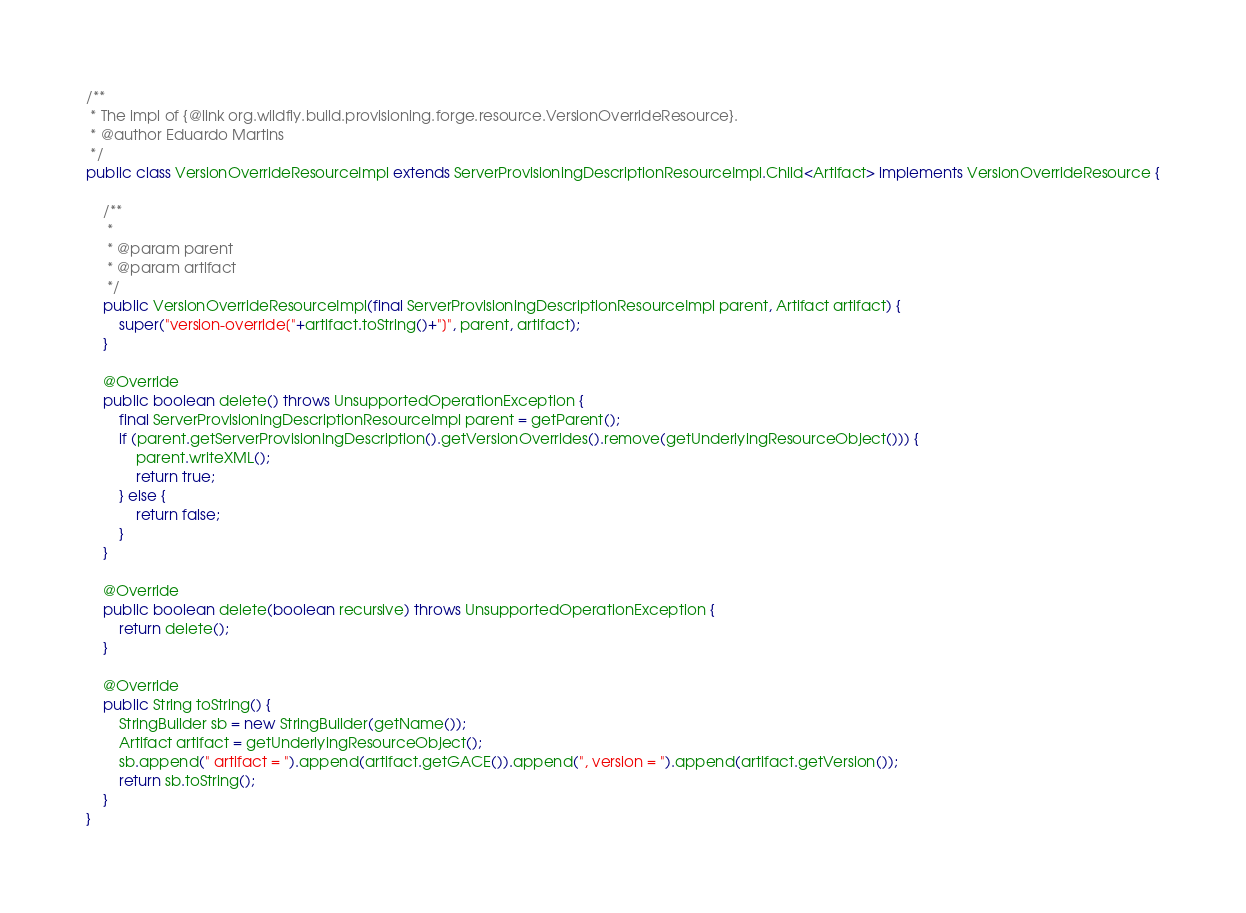<code> <loc_0><loc_0><loc_500><loc_500><_Java_>
/**
 * The impl of {@link org.wildfly.build.provisioning.forge.resource.VersionOverrideResource}.
 * @author Eduardo Martins
 */
public class VersionOverrideResourceImpl extends ServerProvisioningDescriptionResourceImpl.Child<Artifact> implements VersionOverrideResource {

    /**
     *
     * @param parent
     * @param artifact
     */
    public VersionOverrideResourceImpl(final ServerProvisioningDescriptionResourceImpl parent, Artifact artifact) {
        super("version-override["+artifact.toString()+"]", parent, artifact);
    }

    @Override
    public boolean delete() throws UnsupportedOperationException {
        final ServerProvisioningDescriptionResourceImpl parent = getParent();
        if (parent.getServerProvisioningDescription().getVersionOverrides().remove(getUnderlyingResourceObject())) {
            parent.writeXML();
            return true;
        } else {
            return false;
        }
    }

    @Override
    public boolean delete(boolean recursive) throws UnsupportedOperationException {
        return delete();
    }

    @Override
    public String toString() {
        StringBuilder sb = new StringBuilder(getName());
        Artifact artifact = getUnderlyingResourceObject();
        sb.append(" artifact = ").append(artifact.getGACE()).append(", version = ").append(artifact.getVersion());
        return sb.toString();
    }
}</code> 